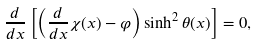Convert formula to latex. <formula><loc_0><loc_0><loc_500><loc_500>\frac { d } { d x } \left [ \left ( \frac { d } { d x } \chi ( x ) - \varphi \right ) \sinh ^ { 2 } \theta ( x ) \right ] = 0 ,</formula> 